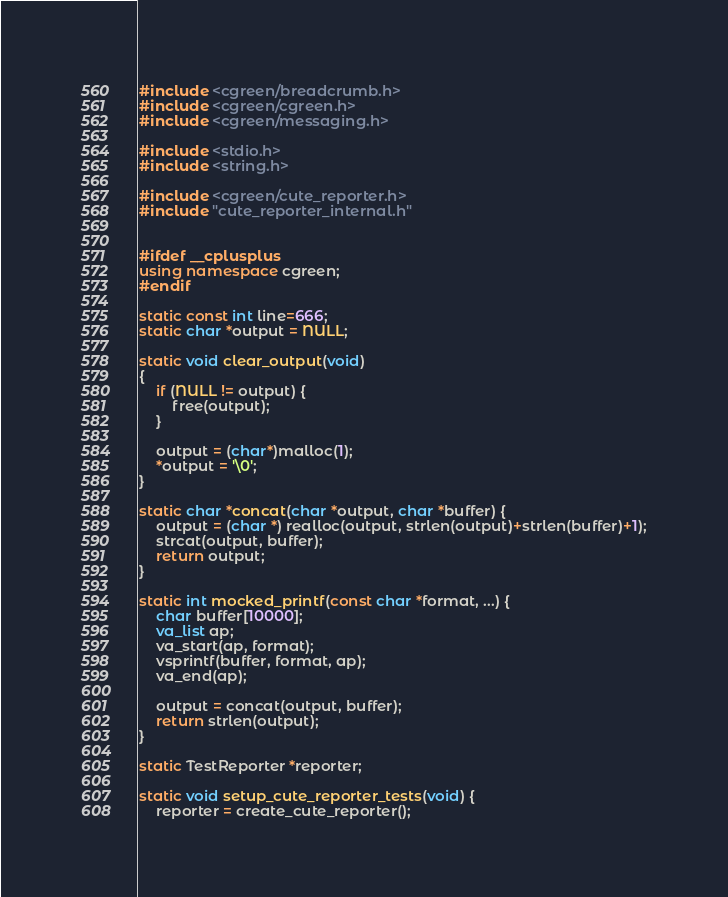<code> <loc_0><loc_0><loc_500><loc_500><_C++_>
#include <cgreen/breadcrumb.h>
#include <cgreen/cgreen.h>
#include <cgreen/messaging.h>

#include <stdio.h>
#include <string.h>

#include <cgreen/cute_reporter.h>
#include "cute_reporter_internal.h"


#ifdef __cplusplus
using namespace cgreen;
#endif

static const int line=666;
static char *output = NULL;

static void clear_output(void)
{
    if (NULL != output) {
        free(output);
    }

    output = (char*)malloc(1);
    *output = '\0';
}

static char *concat(char *output, char *buffer) {
    output = (char *) realloc(output, strlen(output)+strlen(buffer)+1);
    strcat(output, buffer);
    return output;
}

static int mocked_printf(const char *format, ...) {
    char buffer[10000];
    va_list ap;
    va_start(ap, format);
    vsprintf(buffer, format, ap);
    va_end(ap);

    output = concat(output, buffer);
    return strlen(output);
}

static TestReporter *reporter;

static void setup_cute_reporter_tests(void) {
    reporter = create_cute_reporter();
</code> 